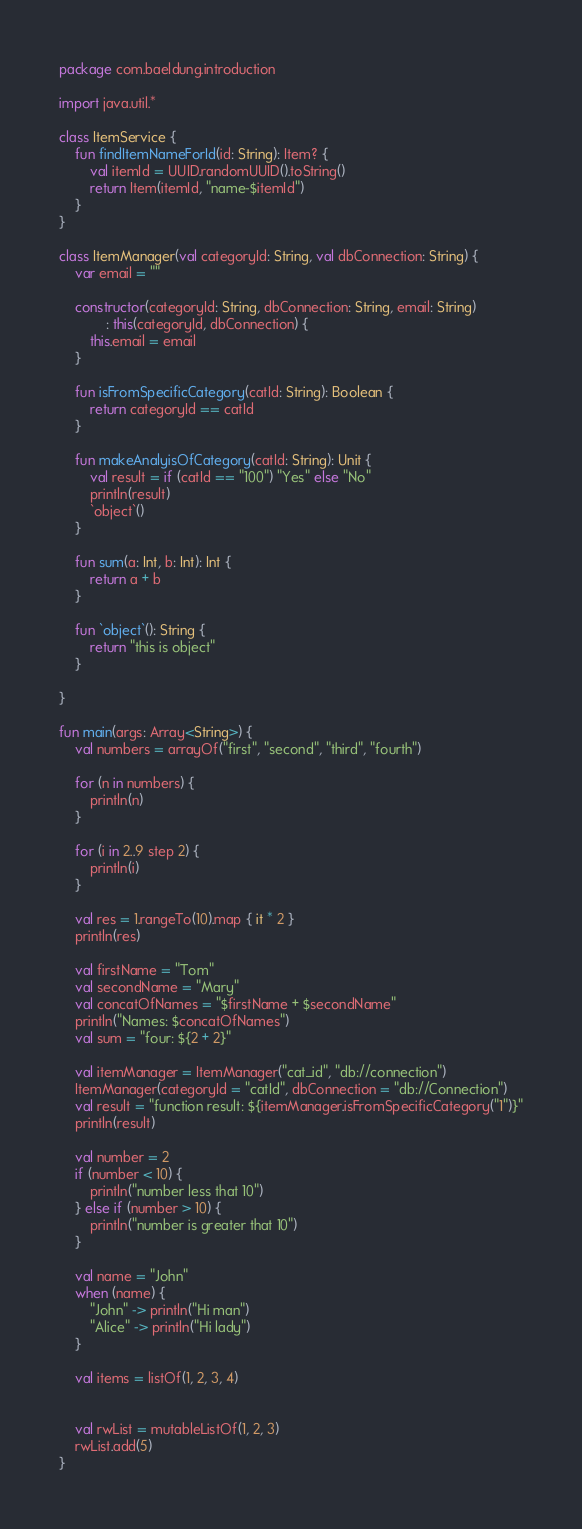<code> <loc_0><loc_0><loc_500><loc_500><_Kotlin_>package com.baeldung.introduction

import java.util.*

class ItemService {
    fun findItemNameForId(id: String): Item? {
        val itemId = UUID.randomUUID().toString()
        return Item(itemId, "name-$itemId")
    }
}

class ItemManager(val categoryId: String, val dbConnection: String) {
    var email = ""

    constructor(categoryId: String, dbConnection: String, email: String)
            : this(categoryId, dbConnection) {
        this.email = email
    }

    fun isFromSpecificCategory(catId: String): Boolean {
        return categoryId == catId
    }

    fun makeAnalyisOfCategory(catId: String): Unit {
        val result = if (catId == "100") "Yes" else "No"
        println(result)
        `object`()
    }

    fun sum(a: Int, b: Int): Int {
        return a + b
    }

    fun `object`(): String {
        return "this is object"
    }

}

fun main(args: Array<String>) {
    val numbers = arrayOf("first", "second", "third", "fourth")

    for (n in numbers) {
        println(n)
    }

    for (i in 2..9 step 2) {
        println(i)
    }

    val res = 1.rangeTo(10).map { it * 2 }
    println(res)

    val firstName = "Tom"
    val secondName = "Mary"
    val concatOfNames = "$firstName + $secondName"
    println("Names: $concatOfNames")
    val sum = "four: ${2 + 2}"

    val itemManager = ItemManager("cat_id", "db://connection")
    ItemManager(categoryId = "catId", dbConnection = "db://Connection")
    val result = "function result: ${itemManager.isFromSpecificCategory("1")}"
    println(result)

    val number = 2
    if (number < 10) {
        println("number less that 10")
    } else if (number > 10) {
        println("number is greater that 10")
    }

    val name = "John"
    when (name) {
        "John" -> println("Hi man")
        "Alice" -> println("Hi lady")
    }

    val items = listOf(1, 2, 3, 4)


    val rwList = mutableListOf(1, 2, 3)
    rwList.add(5)
}</code> 